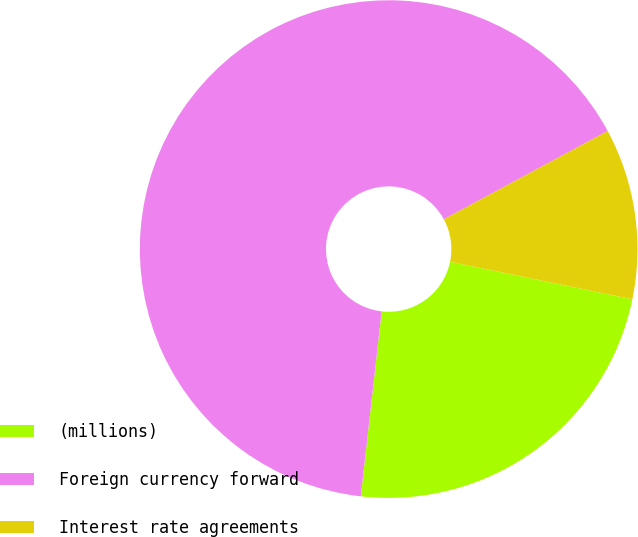<chart> <loc_0><loc_0><loc_500><loc_500><pie_chart><fcel>(millions)<fcel>Foreign currency forward<fcel>Interest rate agreements<nl><fcel>23.56%<fcel>65.34%<fcel>11.1%<nl></chart> 